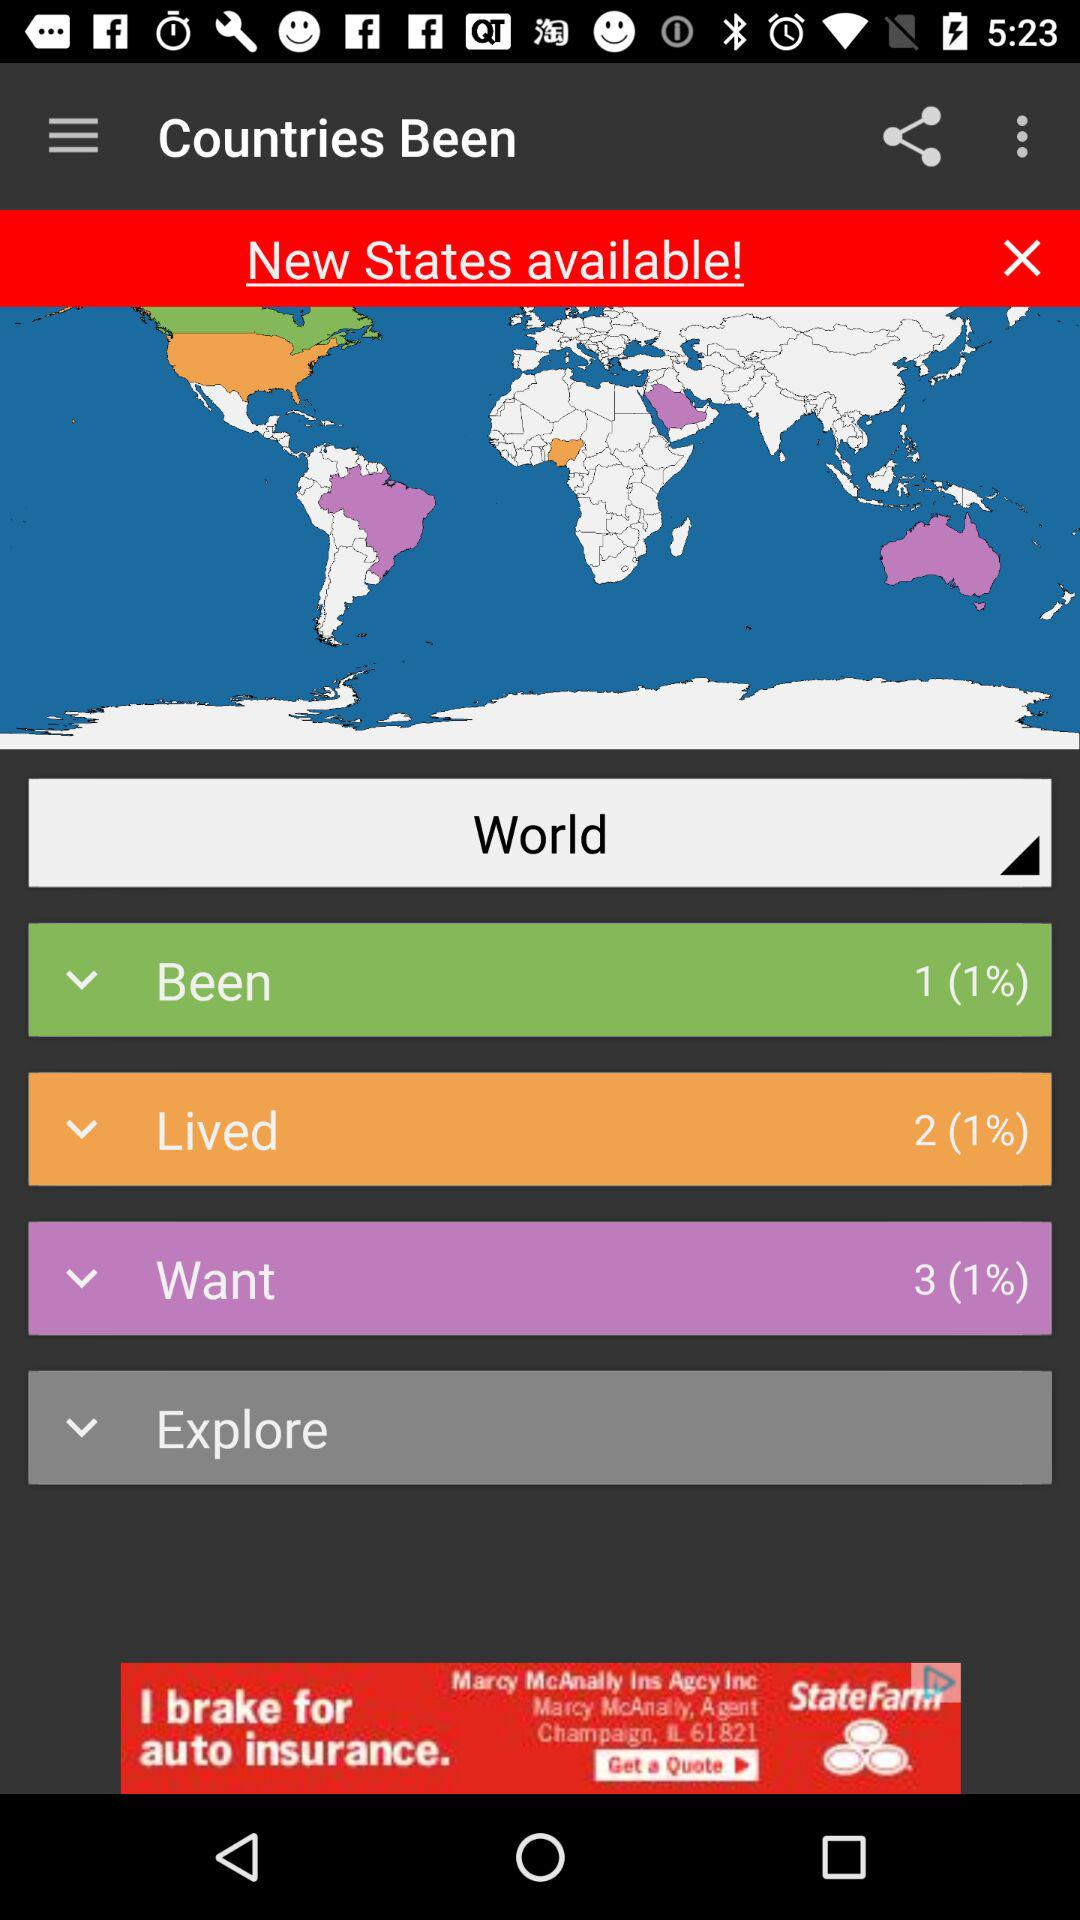What is the name of the application? The name of the application is "Countries Been". 